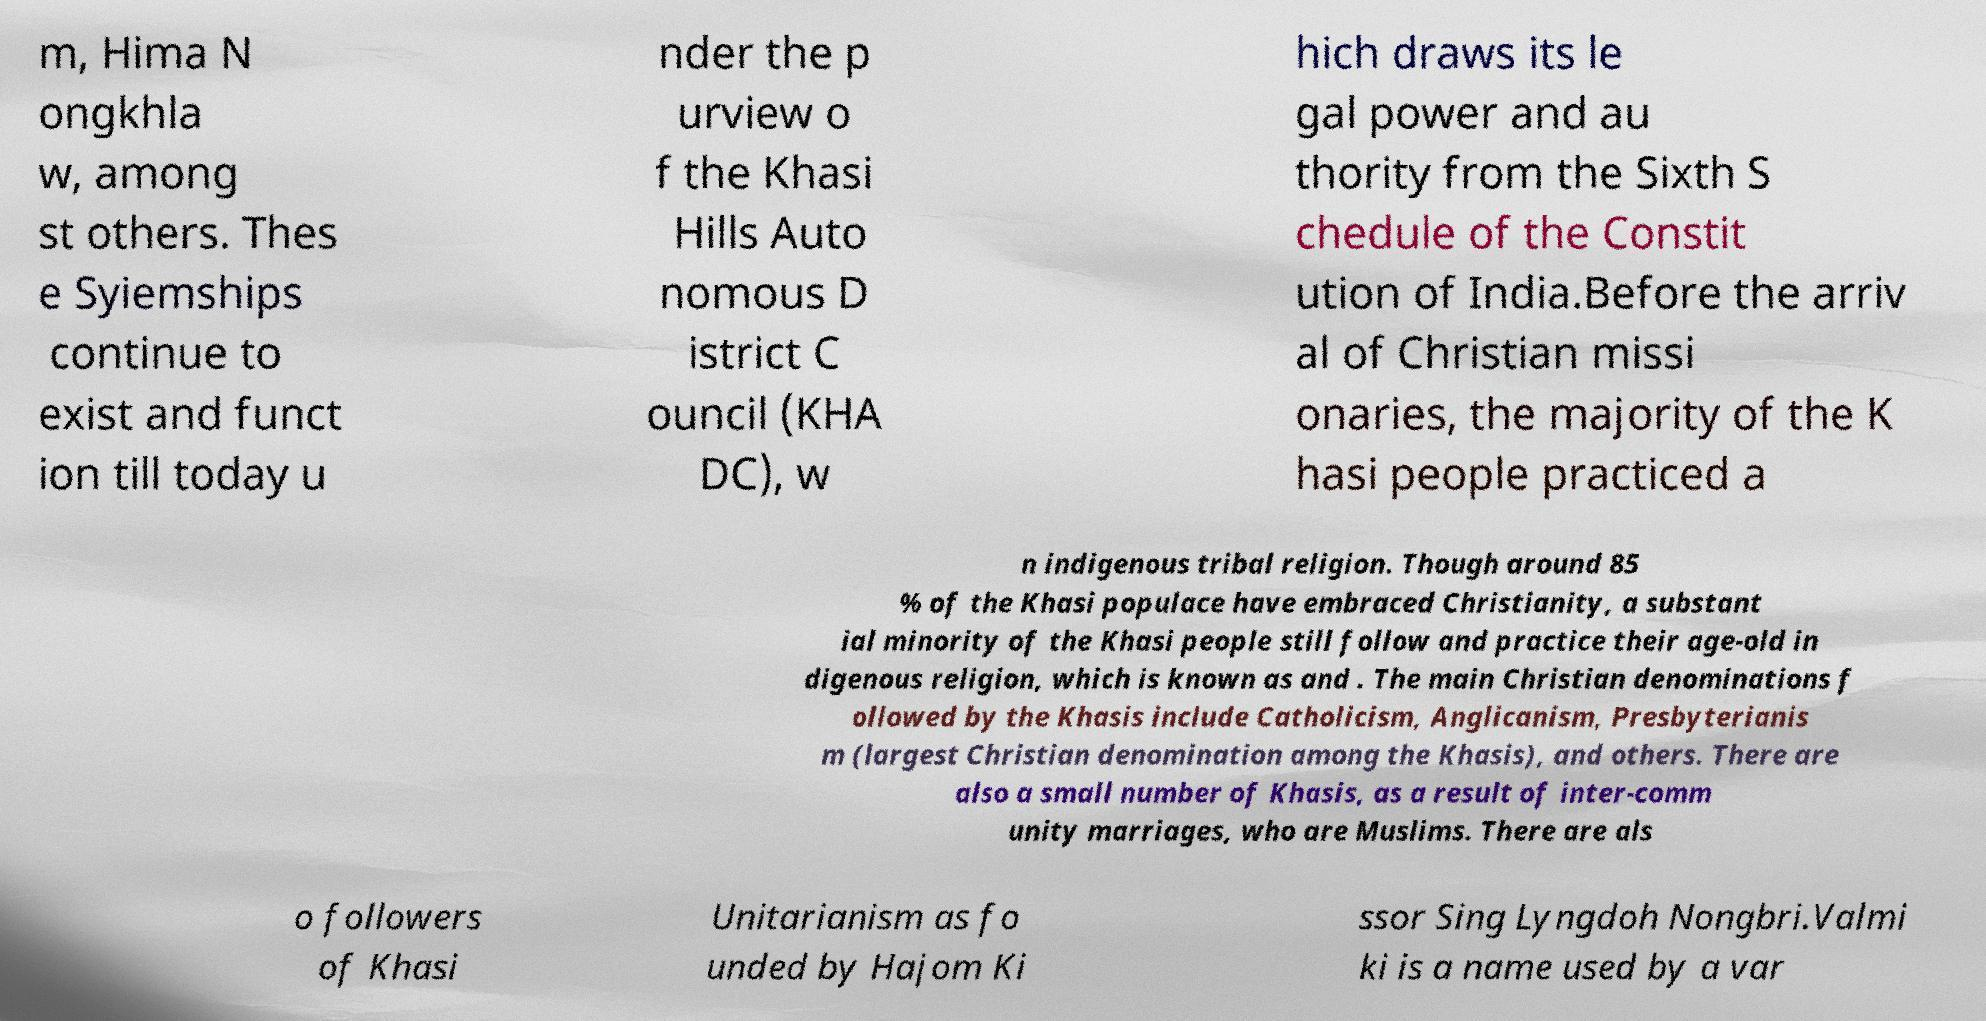What messages or text are displayed in this image? I need them in a readable, typed format. m, Hima N ongkhla w, among st others. Thes e Syiemships continue to exist and funct ion till today u nder the p urview o f the Khasi Hills Auto nomous D istrict C ouncil (KHA DC), w hich draws its le gal power and au thority from the Sixth S chedule of the Constit ution of India.Before the arriv al of Christian missi onaries, the majority of the K hasi people practiced a n indigenous tribal religion. Though around 85 % of the Khasi populace have embraced Christianity, a substant ial minority of the Khasi people still follow and practice their age-old in digenous religion, which is known as and . The main Christian denominations f ollowed by the Khasis include Catholicism, Anglicanism, Presbyterianis m (largest Christian denomination among the Khasis), and others. There are also a small number of Khasis, as a result of inter-comm unity marriages, who are Muslims. There are als o followers of Khasi Unitarianism as fo unded by Hajom Ki ssor Sing Lyngdoh Nongbri.Valmi ki is a name used by a var 